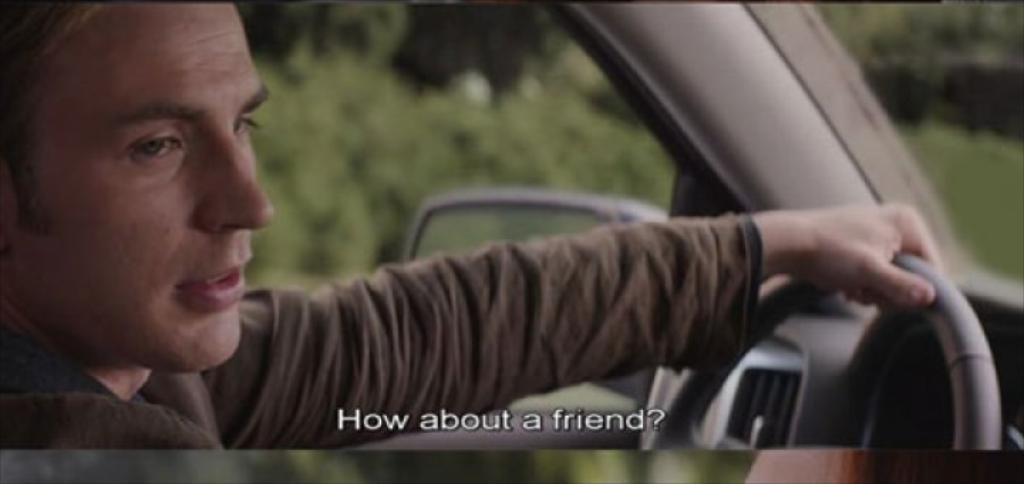What is the main subject of the image? There is a person in the image. What is the person doing in the image? The person is sitting in a car. What color are the goat's eyes in the image? There is no goat present in the image, so it is not possible to determine the color of its eyes. 